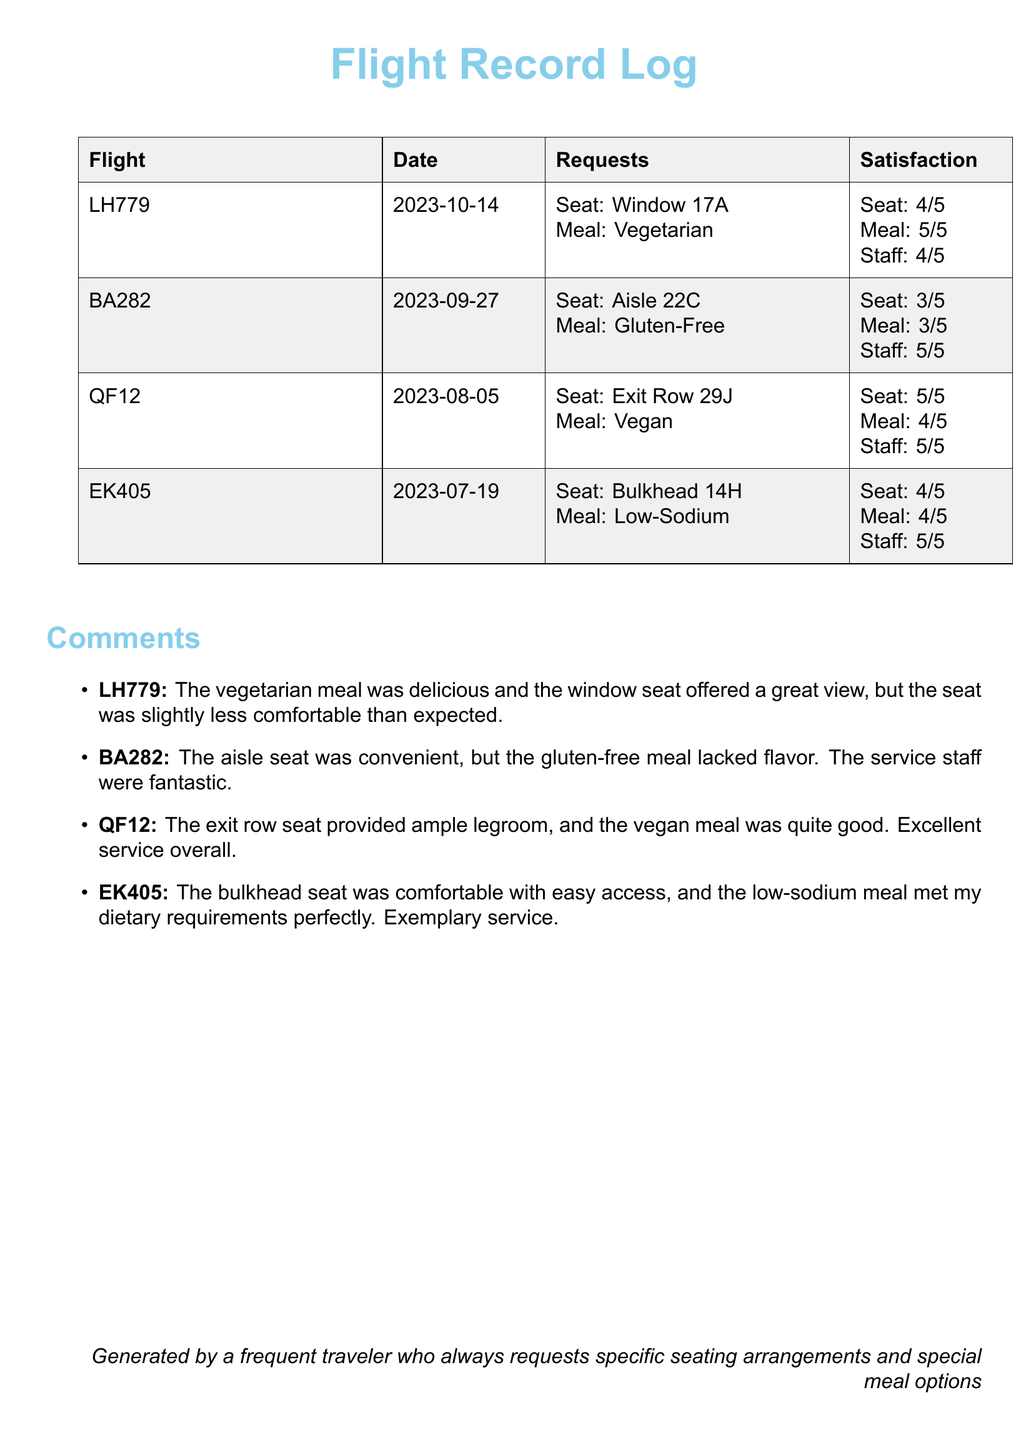What was the satisfaction rating for the meal on flight LH779? The satisfaction rating for the meal on flight LH779 is found in the document under the date and requests, which is listed as 5/5.
Answer: 5/5 Which flight had the highest seat satisfaction rating? The highest seat satisfaction rating can be determined by comparing all ratings in the document, which shows that flight QF12 has the highest rating of 5/5.
Answer: QF12 What type of meal was requested on flight BA282? The type of meal requested on flight BA282 is specified in the requests section, which indicates it was a gluten-free meal.
Answer: Gluten-Free How many flights had a satisfaction rating of 4 or higher for the meal? By observing the meal satisfaction ratings in the document, we can determine that LH779, QF12, and EK405 all have ratings of 4 or higher.
Answer: 3 What comments were made regarding the aisle seat on flight BA282? The comments related to the aisle seat on BA282 highlight that it was convenient, providing specific feedback on comfort and service.
Answer: Convenient, but the gluten-free meal lacked flavor Which flight had a low-sodium meal? The specific flight that had a low-sodium meal is mentioned in the requests section as EK405.
Answer: EK405 What was the overall service satisfaction rating on flight EK405? The overall service satisfaction rating for flight EK405 is included in the satisfaction section, and it is rated as 5/5.
Answer: 5/5 What type of seat was requested on flight QF12? The type of seat requested on flight QF12 is stated in the requests, identifying it as an exit row seat.
Answer: Exit Row 29J Which flight recorded comments about excellent service? The comments indicating excellent service are associated with flight QF12, as clearly outlined in the comments section.
Answer: QF12 